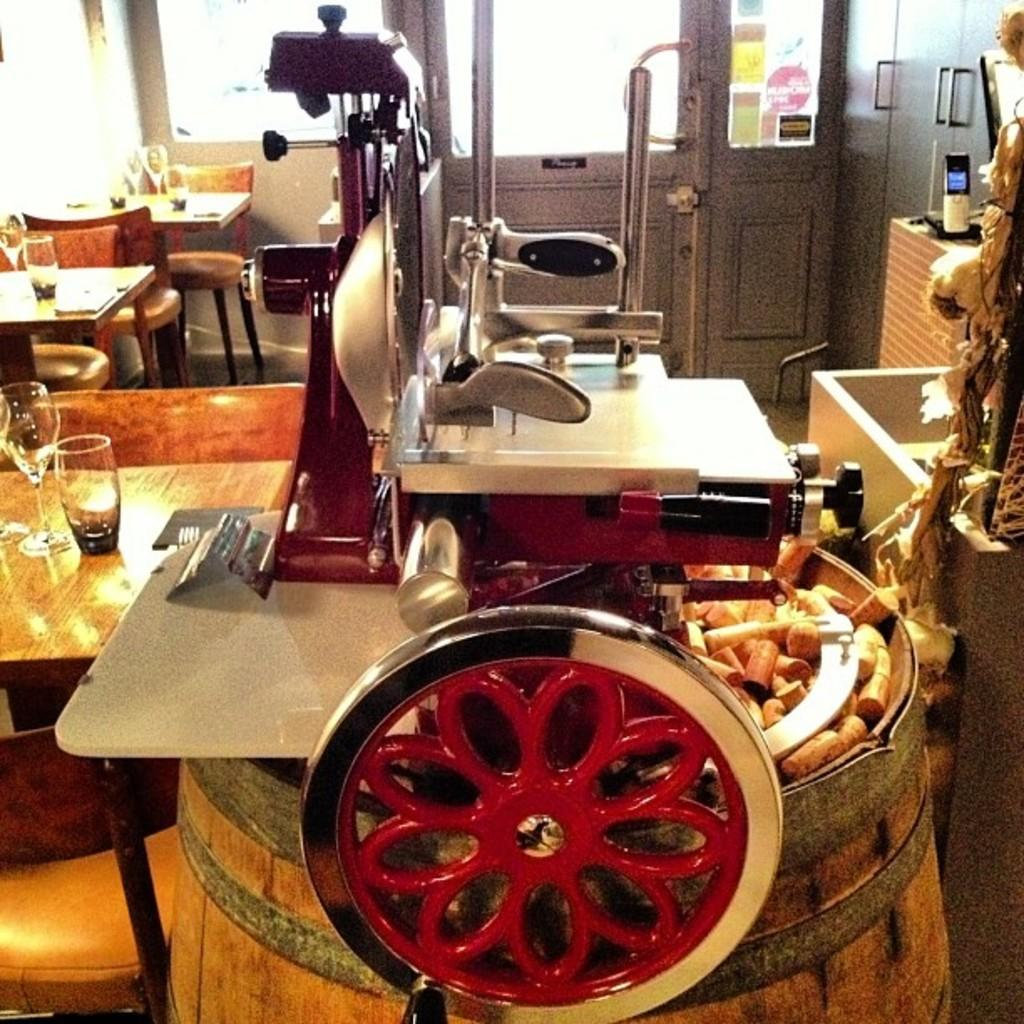What type of furniture can be seen in the image? There are chairs and tables in the image. What is the primary purpose of the door in the image? The door in the image is likely used for entering or exiting a room or space. What objects are on the table in the image? There are glasses on the table in the image. How much money is on the table in the image? There is no mention of money in the image; it only shows glasses on the table. What type of yam is being used as a decoration in the image? There is no yam present in the image. 